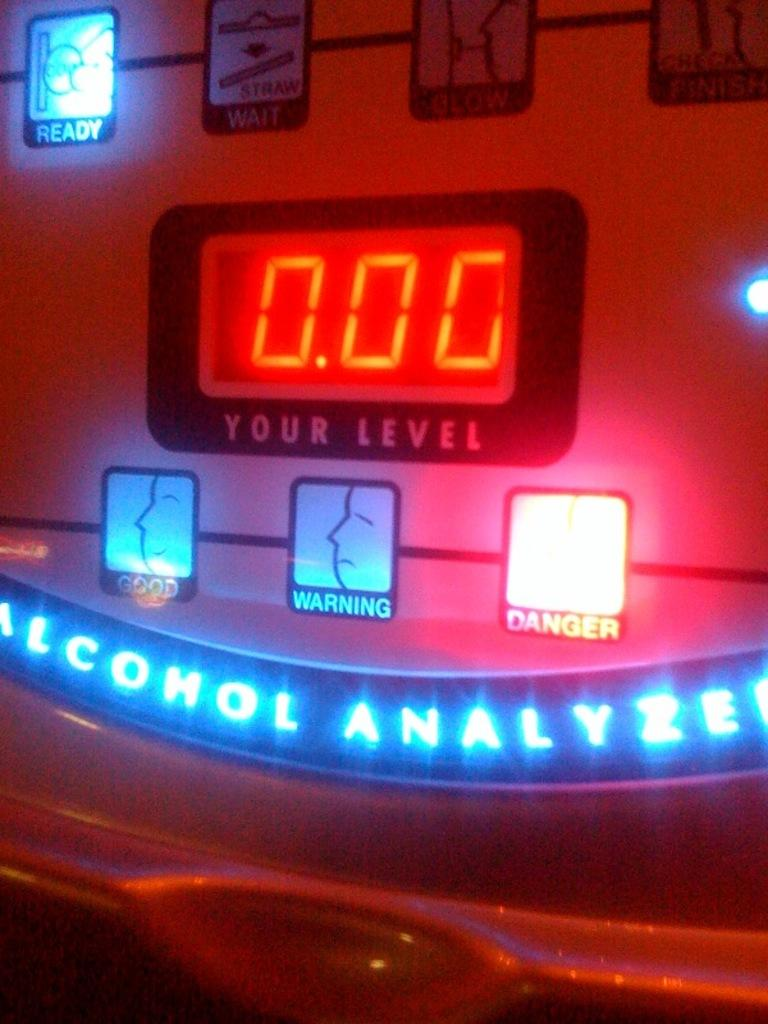<image>
Provide a brief description of the given image. a machine that is an alcahol analyzer that tells your level 